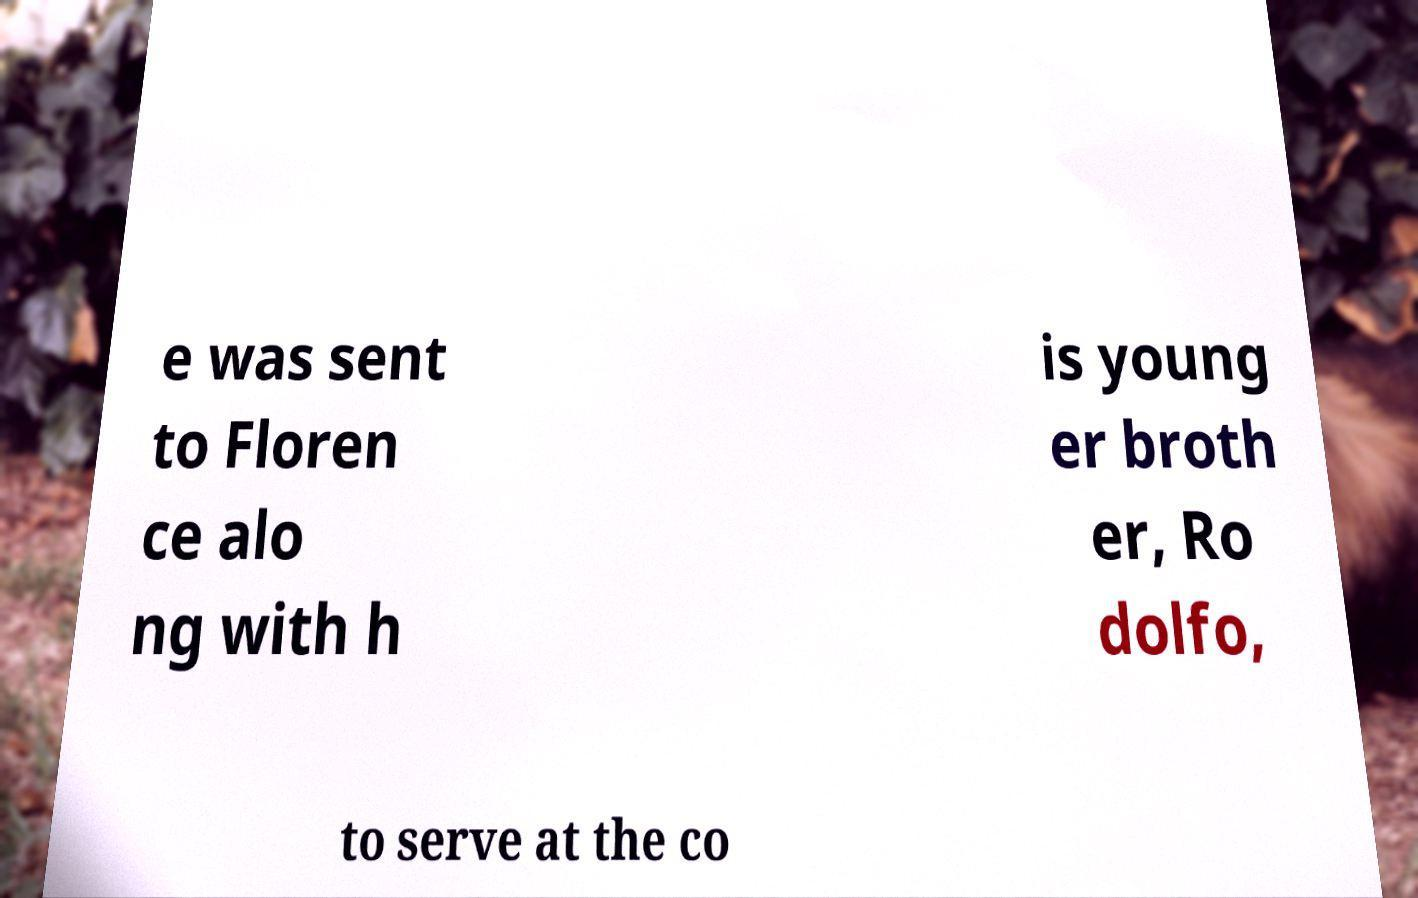There's text embedded in this image that I need extracted. Can you transcribe it verbatim? e was sent to Floren ce alo ng with h is young er broth er, Ro dolfo, to serve at the co 